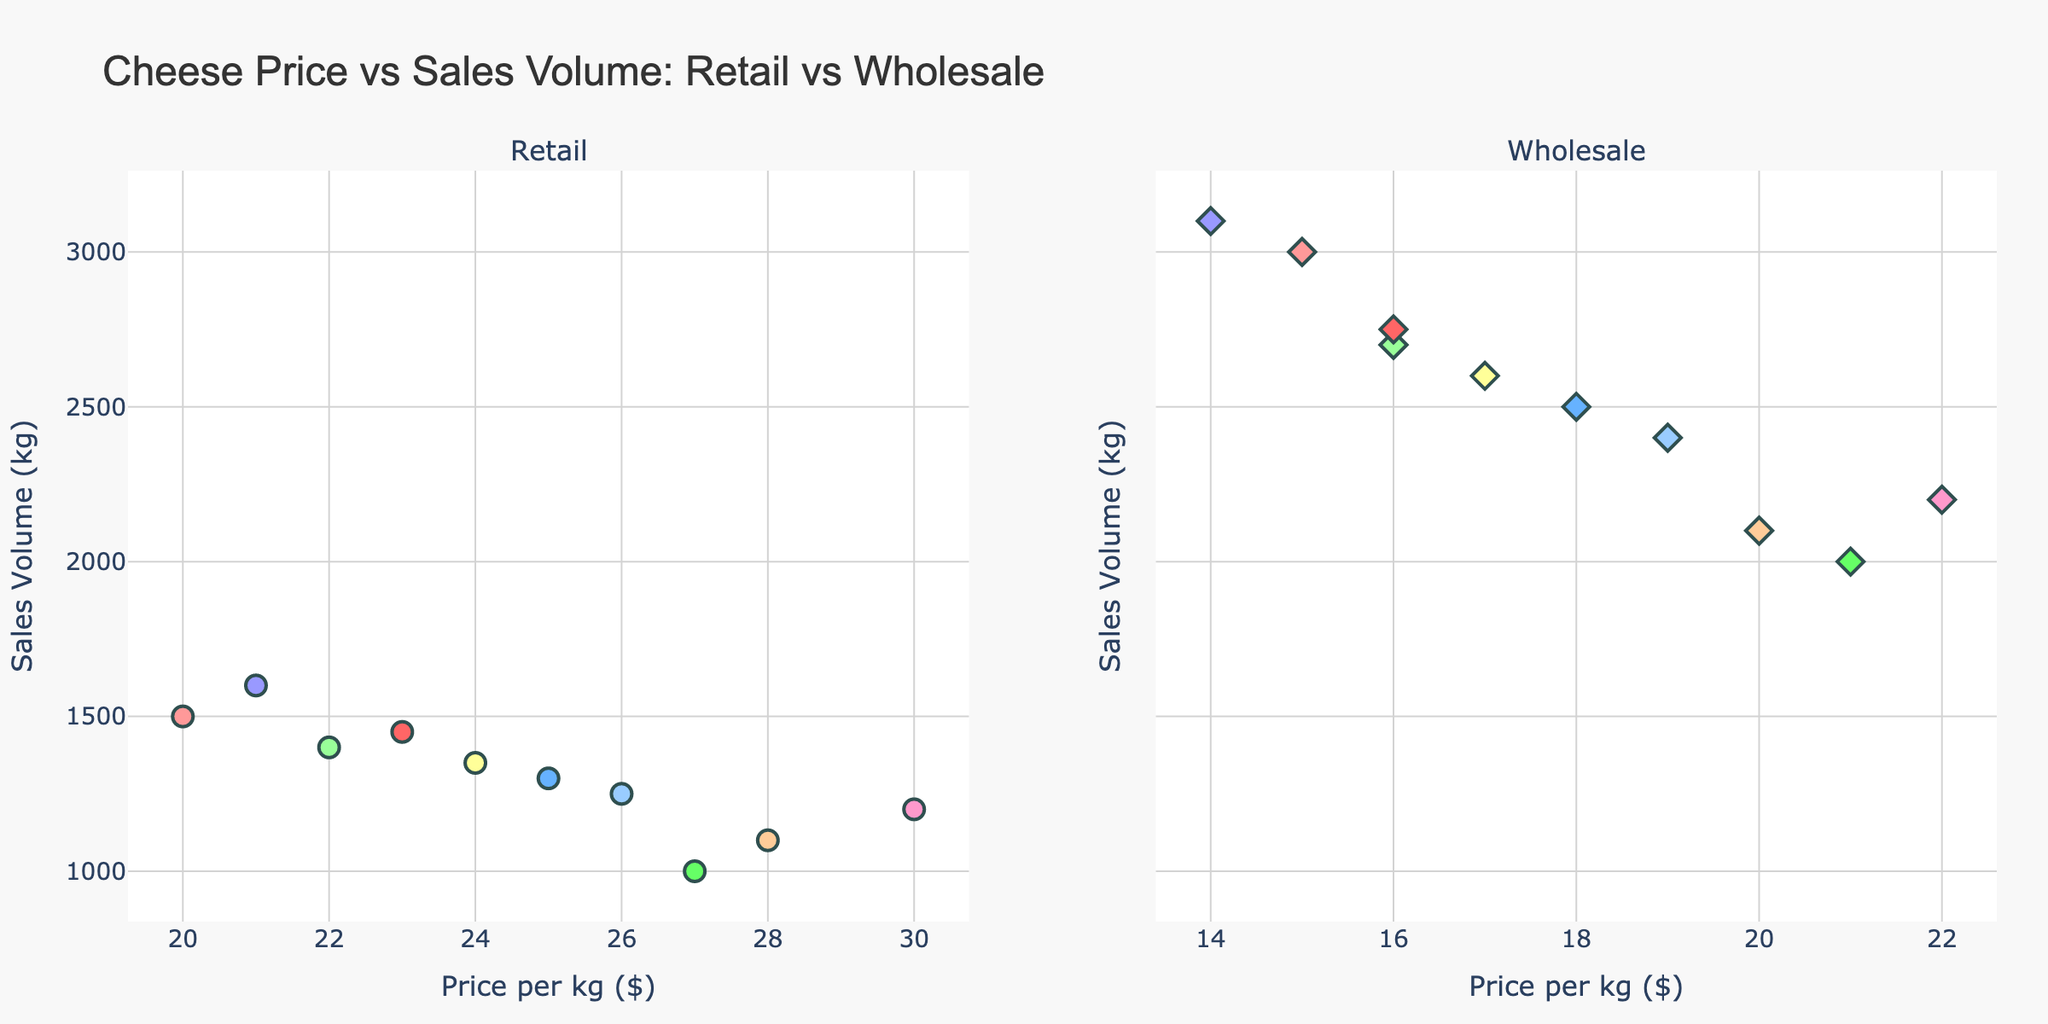What's the overall title of the figure? Look at the top of the figure where the title is displayed. It states the overall theme or topic of the visualized data.
Answer: "Cheese Price vs Sales Volume: Retail vs Wholesale" How many cheese types are represented in each subplot? Count the number of different cheese types plotted in each of the two subplots, one for retail and one for wholesale.
Answer: 10 What is the price per kg of cheese with the highest sales volume in the retail subplot? Identify the highest point on the Y-axis in the retail subplot, which signifies the highest sales volume, and check its corresponding X-axis value for the price.
Answer: $21 Which cheese type has almost equal sales volume in both retail and wholesale distributions? Look for a cheese type plotted closely together in terms of the Y-axis between the two subplots.
Answer: Parmesan What's the difference in sales volume between retail and wholesale for Camembert cheese? Locate Camembert in both subplots and subtract its retail sales volume from its wholesale sales volume: 2000 kg (Wholesale) - 1000 kg (Retail).
Answer: 1000 kg Which subplot shows a wider range of prices per kg? Compare the range of X-axis values (prices per kg) between the retail and wholesale subplots to determine which one has a broader range.
Answer: Retail Which cheese type has the highest price point in the retail subplot? Identify the data point furthest to the right on the X-axis in the retail subplot, indicating the highest price per kg.
Answer: Parmesan What is the average sales volume in the wholesale subplot? Sum all the Y-axis values (sales volumes in kg) in the wholesale subplot and divide by the number of data points: (3000 + 2500 + 2700 + 2100 + 2200 + 2400 + 2600 + 2750 + 2000 + 3100) / 10.
Answer: 2535 kg Is the price per kg for Brie higher in retail or wholesale? Compare the X-axis values for Brie in both the retail and wholesale subplots to see which one is higher.
Answer: Retail 